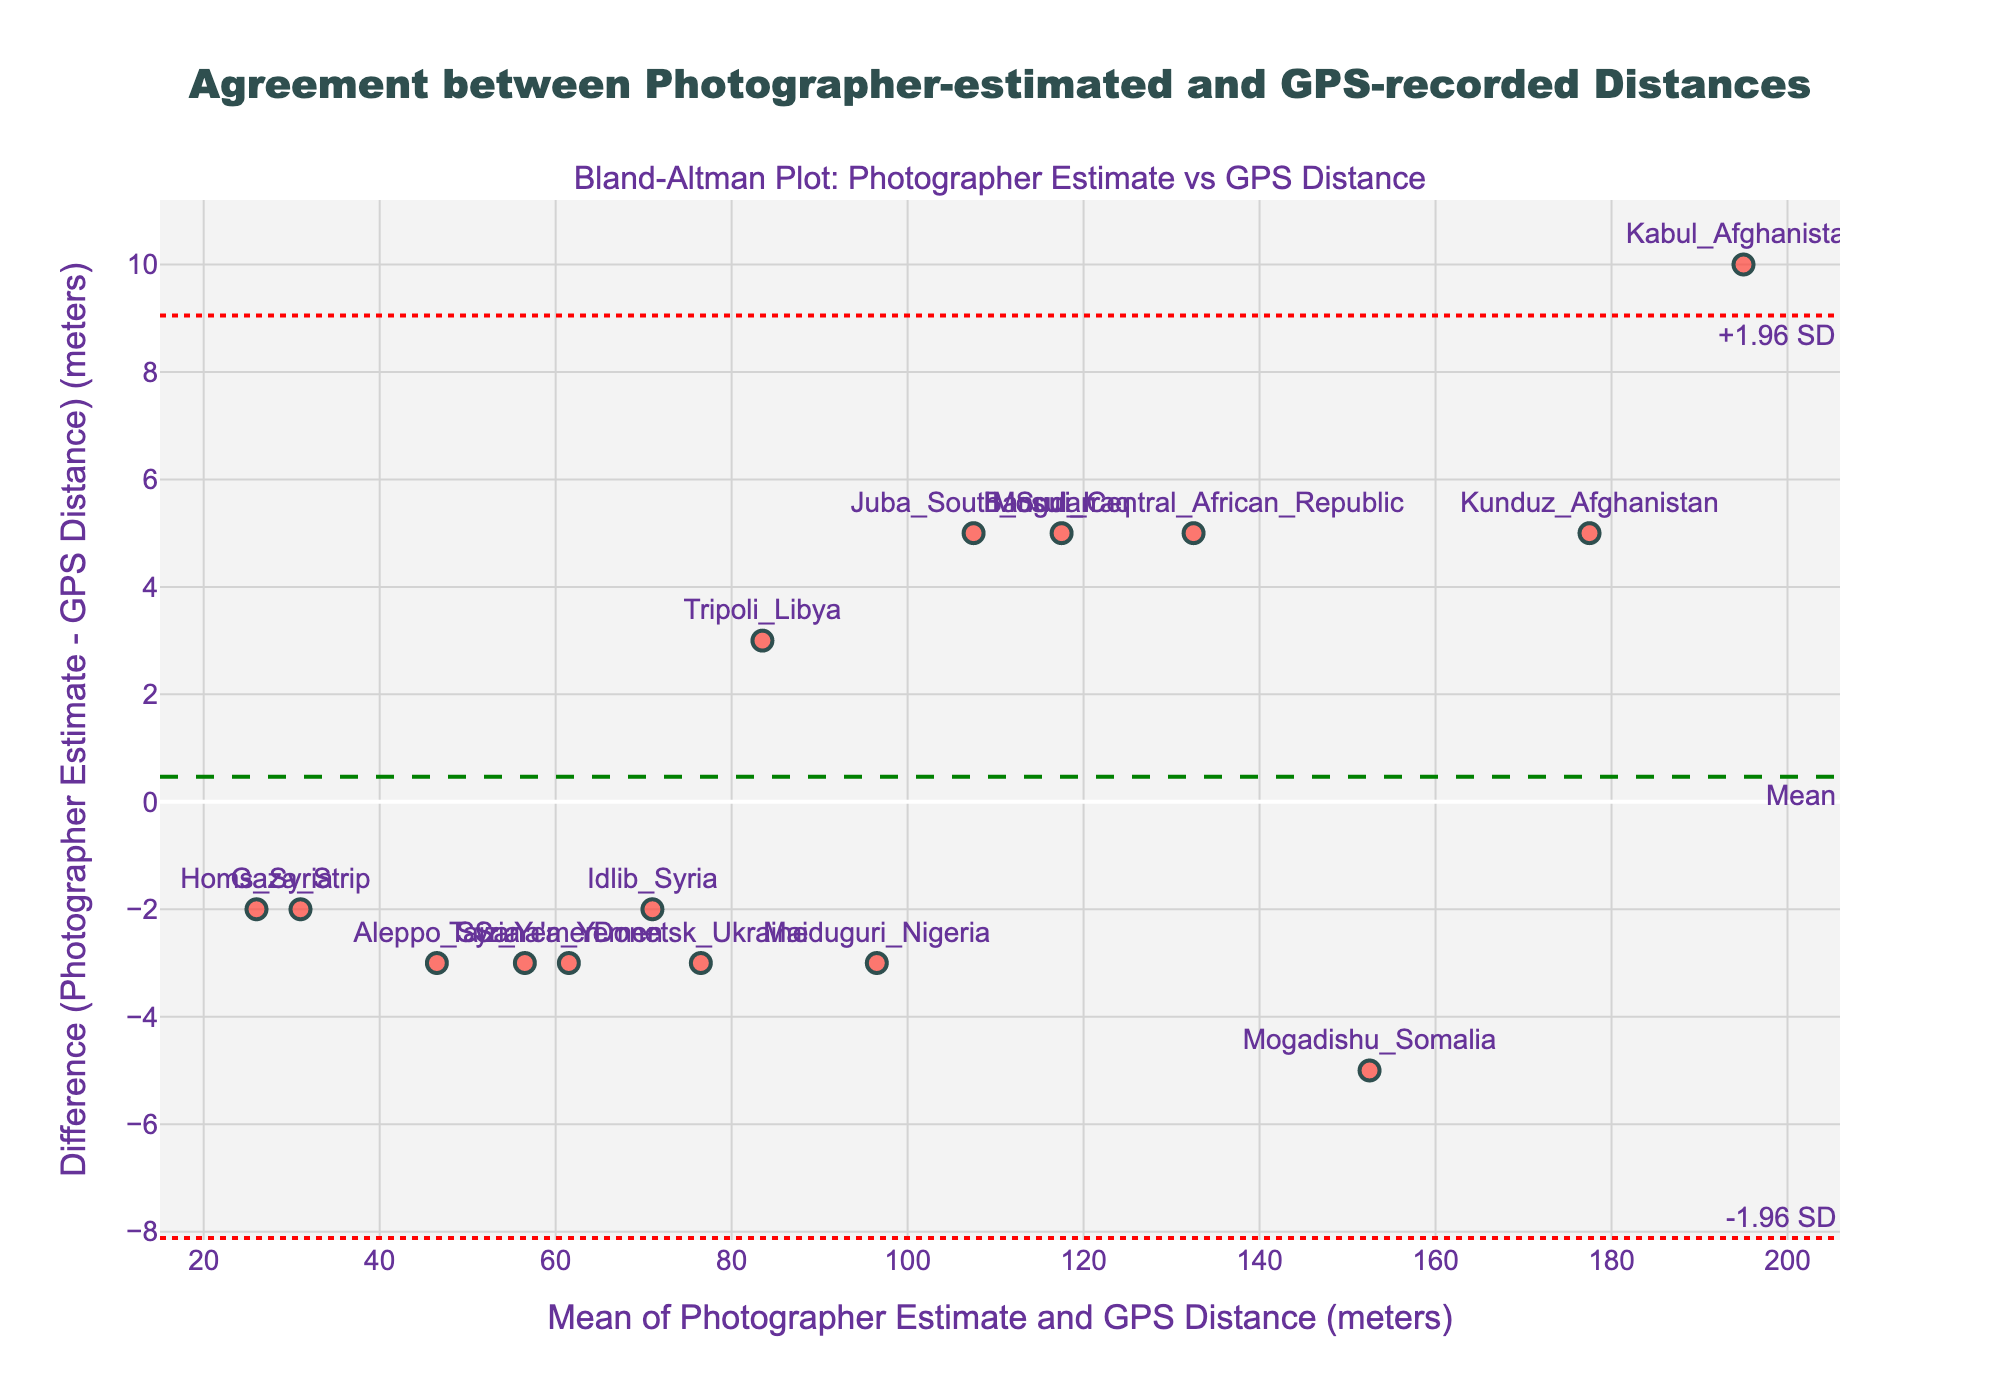What is the title of the figure? The title is written at the top and provides a summary of what the figure represents.
Answer: Agreement between Photographer-estimated and GPS-recorded Distances What do the x-axis and y-axis represent on the plot? The x-axis represents the mean of Photographer Estimate and GPS Distance in meters, while the y-axis represents the difference (Photographer Estimate - GPS Distance) in meters. This information can be found in the axis titles.
Answer: Mean of Photographer Estimate and GPS Distance, Difference How many data points are shown on the plot? Each marker on the plot represents a data point. By counting the markers, we can determine the total number.
Answer: 15 Which location has the highest difference between the photographer's estimate and the GPS distance? Locate the point with the highest y-axis value. The corresponding text label indicates the location.
Answer: Kabul_Afghanistan What is the mean difference between the photographer's estimates and the GPS distances? The mean difference is shown by the horizontal dashed line and is annotated with the word "Mean".
Answer: Approximately 0 Which locations are closest to the mean difference line? Identify the data points (markers) that are closest to the dashed line representing the mean difference.
Answer: Donetsk_Ukraine, Tripoli_Libya What are the upper and lower limits of agreement (LOA) in the plot? The upper LOA is the dotted line above the mean annotated with "+1.96 SD," and the lower LOA is the dotted line below the mean annotated with "-1.96 SD."
Answer: Upper LOA: 15.84, Lower LOA: -15.84 Which location has the most underestimated distance by the photographer? Find the point with the lowest y-axis value (most negative difference) and read the corresponding text label.
Answer: Sana'a_Yemen How does the photographer's estimation compare to the GPS distance in Mogadishu, Somalia? Locate the marker corresponding to Mogadishu, Somalia, then determine whether it is above or below the mean difference line to see if it is overestimated or underestimated.
Answer: Overestimated Who underestimated the distances more often, the photographer or the GPS? Count how many points fall below the mean difference line and compare it to the number of points above it. More points below indicate more underestimation by the photographer.
Answer: Underestimated more often by the photographer 